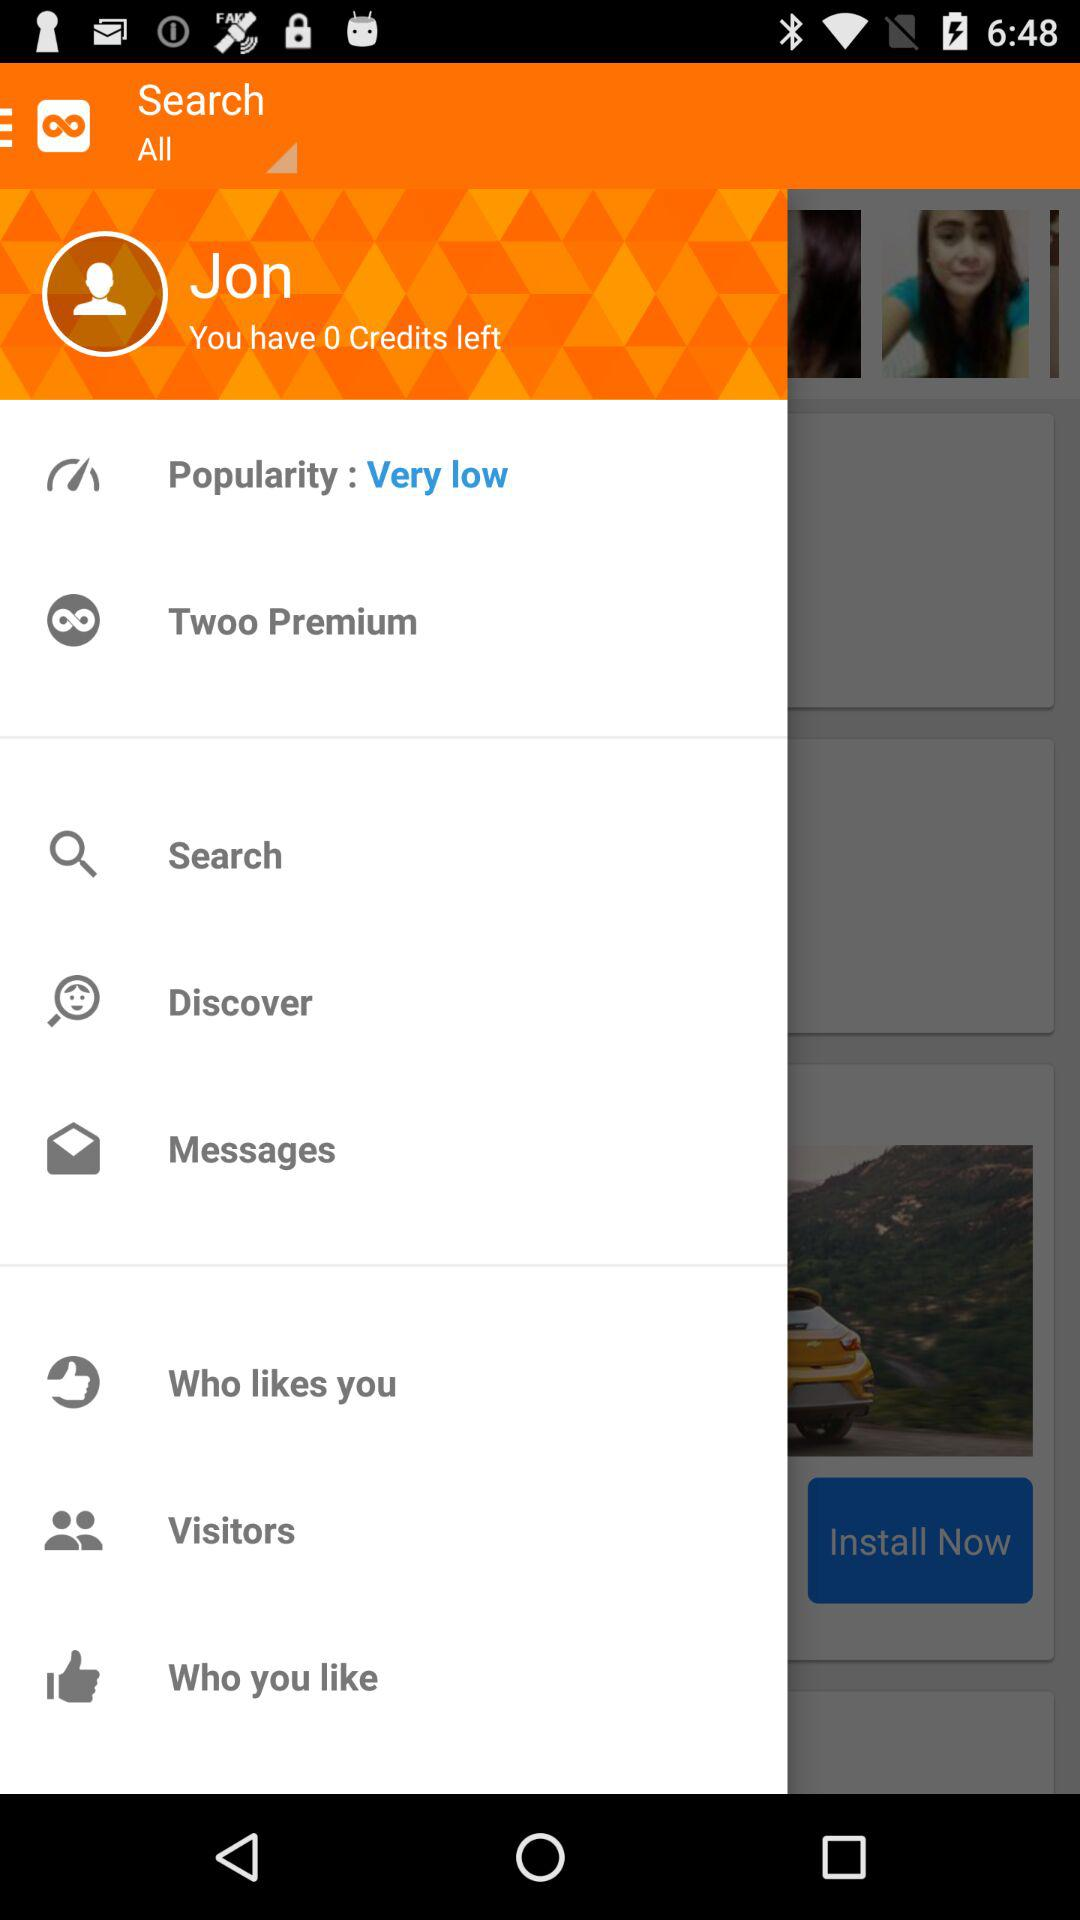What is the name of the user? The name of the user is "Jon". 